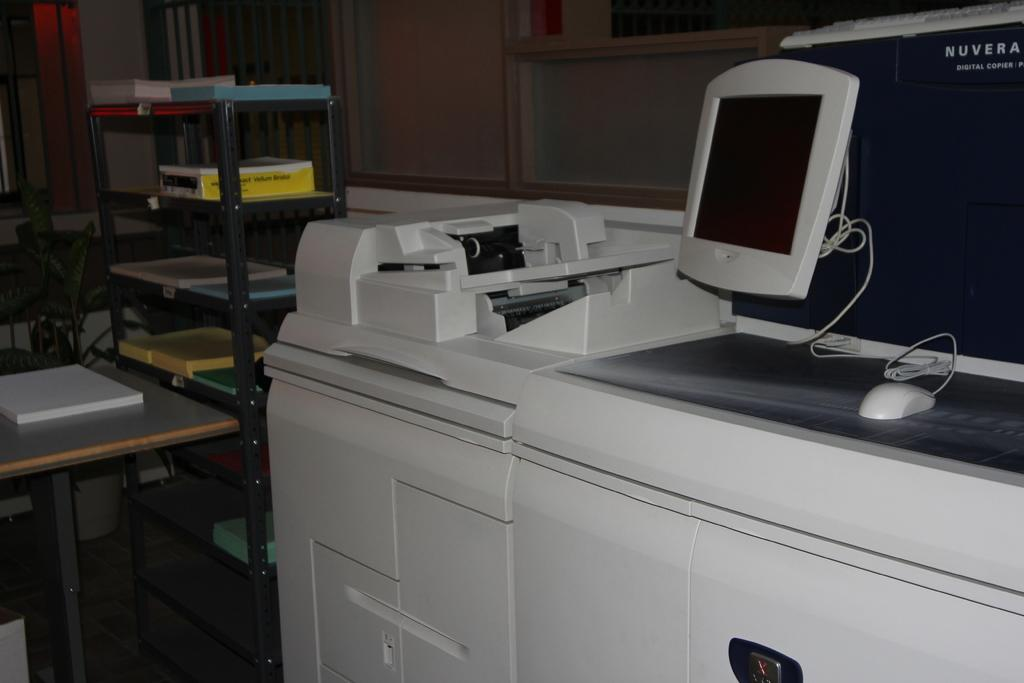<image>
Create a compact narrative representing the image presented. A printing system has the words NUVERA DIGITAL COPIER on one of its components. 